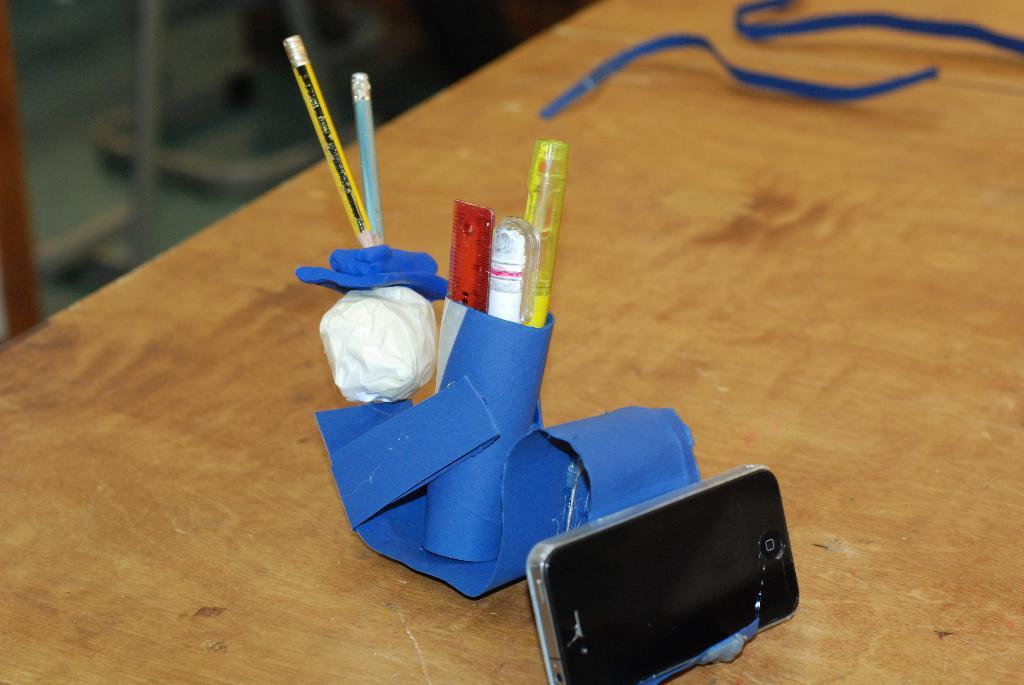What type of object is visible in the image? There is a mobile in the image. What stationery items can be seen in the image? There is a pencil, pens, and papers in the image. How are the pens stored in the image? The pens are stored in a pen holder made with paper in the image. What is the surface made of that the objects are placed on? The objects are on a wooden surface. What is the nature of the blurred area in the image? There is a blurred view in the top left corner of the image. What type of building is visible in the image? There is no building visible in the image; it primarily features stationery items and a mobile. What note can be seen written on the paper in the image? There is no note visible on the paper in the image; the papers are blank. 